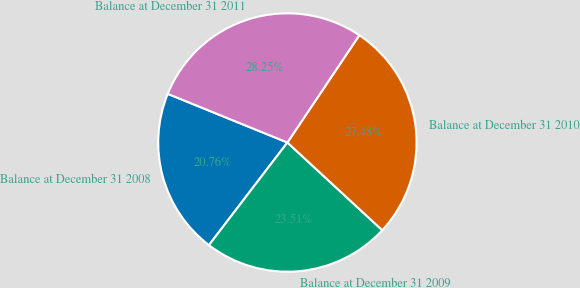Convert chart to OTSL. <chart><loc_0><loc_0><loc_500><loc_500><pie_chart><fcel>Balance at December 31 2008<fcel>Balance at December 31 2009<fcel>Balance at December 31 2010<fcel>Balance at December 31 2011<nl><fcel>20.76%<fcel>23.51%<fcel>27.48%<fcel>28.25%<nl></chart> 